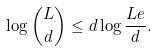Convert formula to latex. <formula><loc_0><loc_0><loc_500><loc_500>\log \binom { L } { d } \leq d \log \frac { L e } { d } .</formula> 